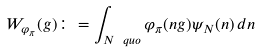<formula> <loc_0><loc_0><loc_500><loc_500>W _ { \varphi _ { \pi } } ( g ) \colon = \int _ { N \ q u o } \varphi _ { \pi } ( n g ) \psi _ { N } ( n ) \, d n</formula> 